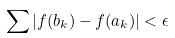<formula> <loc_0><loc_0><loc_500><loc_500>\sum | f ( b _ { k } ) - f ( a _ { k } ) | < \epsilon</formula> 